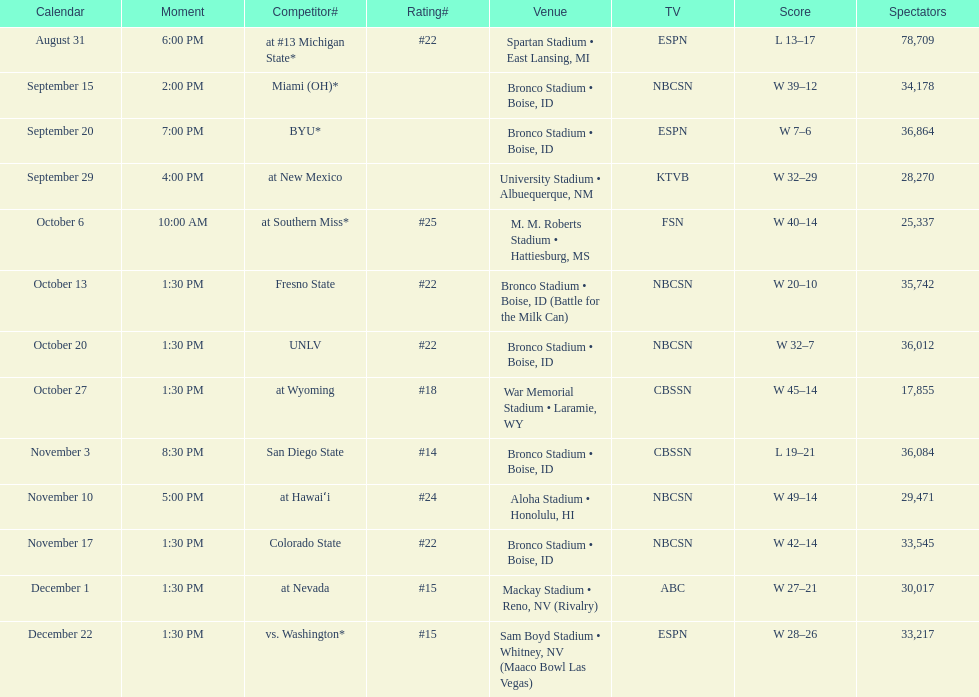Number of points scored by miami (oh) against the broncos. 12. 